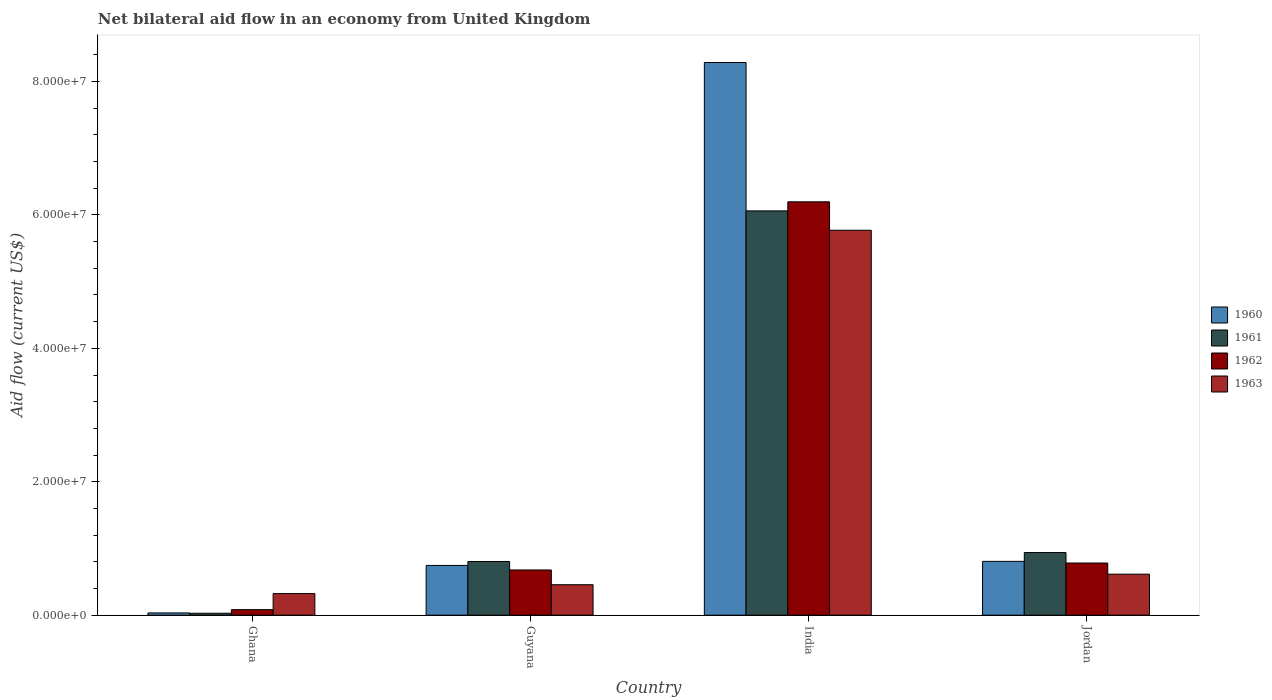How many different coloured bars are there?
Provide a succinct answer. 4. How many groups of bars are there?
Your response must be concise. 4. What is the label of the 3rd group of bars from the left?
Provide a short and direct response. India. In how many cases, is the number of bars for a given country not equal to the number of legend labels?
Offer a very short reply. 0. What is the net bilateral aid flow in 1960 in Guyana?
Keep it short and to the point. 7.46e+06. Across all countries, what is the maximum net bilateral aid flow in 1960?
Provide a short and direct response. 8.28e+07. In which country was the net bilateral aid flow in 1962 minimum?
Ensure brevity in your answer.  Ghana. What is the total net bilateral aid flow in 1962 in the graph?
Ensure brevity in your answer.  7.74e+07. What is the difference between the net bilateral aid flow in 1961 in Guyana and that in Jordan?
Offer a terse response. -1.34e+06. What is the difference between the net bilateral aid flow in 1963 in Guyana and the net bilateral aid flow in 1961 in Ghana?
Keep it short and to the point. 4.28e+06. What is the average net bilateral aid flow in 1960 per country?
Your answer should be very brief. 2.47e+07. What is the difference between the net bilateral aid flow of/in 1960 and net bilateral aid flow of/in 1961 in India?
Keep it short and to the point. 2.22e+07. What is the ratio of the net bilateral aid flow in 1962 in Ghana to that in Guyana?
Provide a short and direct response. 0.12. Is the difference between the net bilateral aid flow in 1960 in Ghana and India greater than the difference between the net bilateral aid flow in 1961 in Ghana and India?
Make the answer very short. No. What is the difference between the highest and the second highest net bilateral aid flow in 1962?
Provide a succinct answer. 5.52e+07. What is the difference between the highest and the lowest net bilateral aid flow in 1961?
Your answer should be compact. 6.03e+07. Is the sum of the net bilateral aid flow in 1961 in Ghana and India greater than the maximum net bilateral aid flow in 1962 across all countries?
Keep it short and to the point. No. Is it the case that in every country, the sum of the net bilateral aid flow in 1963 and net bilateral aid flow in 1960 is greater than the net bilateral aid flow in 1961?
Make the answer very short. Yes. How many countries are there in the graph?
Your answer should be compact. 4. What is the difference between two consecutive major ticks on the Y-axis?
Your answer should be very brief. 2.00e+07. Does the graph contain grids?
Give a very brief answer. No. What is the title of the graph?
Ensure brevity in your answer.  Net bilateral aid flow in an economy from United Kingdom. What is the label or title of the X-axis?
Offer a very short reply. Country. What is the Aid flow (current US$) of 1962 in Ghana?
Provide a short and direct response. 8.30e+05. What is the Aid flow (current US$) of 1963 in Ghana?
Your answer should be very brief. 3.24e+06. What is the Aid flow (current US$) of 1960 in Guyana?
Provide a succinct answer. 7.46e+06. What is the Aid flow (current US$) in 1961 in Guyana?
Ensure brevity in your answer.  8.05e+06. What is the Aid flow (current US$) in 1962 in Guyana?
Keep it short and to the point. 6.78e+06. What is the Aid flow (current US$) in 1963 in Guyana?
Your answer should be very brief. 4.57e+06. What is the Aid flow (current US$) of 1960 in India?
Provide a short and direct response. 8.28e+07. What is the Aid flow (current US$) in 1961 in India?
Make the answer very short. 6.06e+07. What is the Aid flow (current US$) of 1962 in India?
Keep it short and to the point. 6.20e+07. What is the Aid flow (current US$) in 1963 in India?
Provide a succinct answer. 5.77e+07. What is the Aid flow (current US$) in 1960 in Jordan?
Make the answer very short. 8.07e+06. What is the Aid flow (current US$) in 1961 in Jordan?
Your answer should be compact. 9.39e+06. What is the Aid flow (current US$) in 1962 in Jordan?
Make the answer very short. 7.82e+06. What is the Aid flow (current US$) of 1963 in Jordan?
Your answer should be very brief. 6.15e+06. Across all countries, what is the maximum Aid flow (current US$) in 1960?
Make the answer very short. 8.28e+07. Across all countries, what is the maximum Aid flow (current US$) in 1961?
Your answer should be compact. 6.06e+07. Across all countries, what is the maximum Aid flow (current US$) in 1962?
Make the answer very short. 6.20e+07. Across all countries, what is the maximum Aid flow (current US$) in 1963?
Your answer should be very brief. 5.77e+07. Across all countries, what is the minimum Aid flow (current US$) in 1961?
Give a very brief answer. 2.90e+05. Across all countries, what is the minimum Aid flow (current US$) in 1962?
Your response must be concise. 8.30e+05. Across all countries, what is the minimum Aid flow (current US$) in 1963?
Your response must be concise. 3.24e+06. What is the total Aid flow (current US$) in 1960 in the graph?
Offer a terse response. 9.87e+07. What is the total Aid flow (current US$) of 1961 in the graph?
Your answer should be compact. 7.83e+07. What is the total Aid flow (current US$) in 1962 in the graph?
Your response must be concise. 7.74e+07. What is the total Aid flow (current US$) of 1963 in the graph?
Ensure brevity in your answer.  7.17e+07. What is the difference between the Aid flow (current US$) in 1960 in Ghana and that in Guyana?
Provide a short and direct response. -7.12e+06. What is the difference between the Aid flow (current US$) of 1961 in Ghana and that in Guyana?
Offer a very short reply. -7.76e+06. What is the difference between the Aid flow (current US$) in 1962 in Ghana and that in Guyana?
Provide a short and direct response. -5.95e+06. What is the difference between the Aid flow (current US$) of 1963 in Ghana and that in Guyana?
Keep it short and to the point. -1.33e+06. What is the difference between the Aid flow (current US$) in 1960 in Ghana and that in India?
Keep it short and to the point. -8.25e+07. What is the difference between the Aid flow (current US$) of 1961 in Ghana and that in India?
Offer a very short reply. -6.03e+07. What is the difference between the Aid flow (current US$) in 1962 in Ghana and that in India?
Make the answer very short. -6.11e+07. What is the difference between the Aid flow (current US$) in 1963 in Ghana and that in India?
Keep it short and to the point. -5.45e+07. What is the difference between the Aid flow (current US$) of 1960 in Ghana and that in Jordan?
Offer a terse response. -7.73e+06. What is the difference between the Aid flow (current US$) in 1961 in Ghana and that in Jordan?
Your answer should be very brief. -9.10e+06. What is the difference between the Aid flow (current US$) of 1962 in Ghana and that in Jordan?
Make the answer very short. -6.99e+06. What is the difference between the Aid flow (current US$) in 1963 in Ghana and that in Jordan?
Offer a very short reply. -2.91e+06. What is the difference between the Aid flow (current US$) in 1960 in Guyana and that in India?
Ensure brevity in your answer.  -7.54e+07. What is the difference between the Aid flow (current US$) in 1961 in Guyana and that in India?
Your response must be concise. -5.26e+07. What is the difference between the Aid flow (current US$) in 1962 in Guyana and that in India?
Offer a terse response. -5.52e+07. What is the difference between the Aid flow (current US$) of 1963 in Guyana and that in India?
Ensure brevity in your answer.  -5.31e+07. What is the difference between the Aid flow (current US$) of 1960 in Guyana and that in Jordan?
Ensure brevity in your answer.  -6.10e+05. What is the difference between the Aid flow (current US$) in 1961 in Guyana and that in Jordan?
Keep it short and to the point. -1.34e+06. What is the difference between the Aid flow (current US$) of 1962 in Guyana and that in Jordan?
Your response must be concise. -1.04e+06. What is the difference between the Aid flow (current US$) in 1963 in Guyana and that in Jordan?
Your answer should be compact. -1.58e+06. What is the difference between the Aid flow (current US$) of 1960 in India and that in Jordan?
Your response must be concise. 7.48e+07. What is the difference between the Aid flow (current US$) in 1961 in India and that in Jordan?
Offer a very short reply. 5.12e+07. What is the difference between the Aid flow (current US$) of 1962 in India and that in Jordan?
Make the answer very short. 5.41e+07. What is the difference between the Aid flow (current US$) of 1963 in India and that in Jordan?
Provide a succinct answer. 5.16e+07. What is the difference between the Aid flow (current US$) of 1960 in Ghana and the Aid flow (current US$) of 1961 in Guyana?
Offer a very short reply. -7.71e+06. What is the difference between the Aid flow (current US$) of 1960 in Ghana and the Aid flow (current US$) of 1962 in Guyana?
Keep it short and to the point. -6.44e+06. What is the difference between the Aid flow (current US$) of 1960 in Ghana and the Aid flow (current US$) of 1963 in Guyana?
Provide a short and direct response. -4.23e+06. What is the difference between the Aid flow (current US$) of 1961 in Ghana and the Aid flow (current US$) of 1962 in Guyana?
Provide a short and direct response. -6.49e+06. What is the difference between the Aid flow (current US$) of 1961 in Ghana and the Aid flow (current US$) of 1963 in Guyana?
Make the answer very short. -4.28e+06. What is the difference between the Aid flow (current US$) in 1962 in Ghana and the Aid flow (current US$) in 1963 in Guyana?
Keep it short and to the point. -3.74e+06. What is the difference between the Aid flow (current US$) of 1960 in Ghana and the Aid flow (current US$) of 1961 in India?
Keep it short and to the point. -6.03e+07. What is the difference between the Aid flow (current US$) of 1960 in Ghana and the Aid flow (current US$) of 1962 in India?
Your response must be concise. -6.16e+07. What is the difference between the Aid flow (current US$) of 1960 in Ghana and the Aid flow (current US$) of 1963 in India?
Make the answer very short. -5.74e+07. What is the difference between the Aid flow (current US$) in 1961 in Ghana and the Aid flow (current US$) in 1962 in India?
Make the answer very short. -6.17e+07. What is the difference between the Aid flow (current US$) in 1961 in Ghana and the Aid flow (current US$) in 1963 in India?
Offer a terse response. -5.74e+07. What is the difference between the Aid flow (current US$) of 1962 in Ghana and the Aid flow (current US$) of 1963 in India?
Your answer should be very brief. -5.69e+07. What is the difference between the Aid flow (current US$) of 1960 in Ghana and the Aid flow (current US$) of 1961 in Jordan?
Offer a very short reply. -9.05e+06. What is the difference between the Aid flow (current US$) in 1960 in Ghana and the Aid flow (current US$) in 1962 in Jordan?
Provide a short and direct response. -7.48e+06. What is the difference between the Aid flow (current US$) in 1960 in Ghana and the Aid flow (current US$) in 1963 in Jordan?
Your answer should be very brief. -5.81e+06. What is the difference between the Aid flow (current US$) in 1961 in Ghana and the Aid flow (current US$) in 1962 in Jordan?
Your answer should be very brief. -7.53e+06. What is the difference between the Aid flow (current US$) in 1961 in Ghana and the Aid flow (current US$) in 1963 in Jordan?
Make the answer very short. -5.86e+06. What is the difference between the Aid flow (current US$) in 1962 in Ghana and the Aid flow (current US$) in 1963 in Jordan?
Your response must be concise. -5.32e+06. What is the difference between the Aid flow (current US$) in 1960 in Guyana and the Aid flow (current US$) in 1961 in India?
Your answer should be very brief. -5.31e+07. What is the difference between the Aid flow (current US$) of 1960 in Guyana and the Aid flow (current US$) of 1962 in India?
Offer a very short reply. -5.45e+07. What is the difference between the Aid flow (current US$) of 1960 in Guyana and the Aid flow (current US$) of 1963 in India?
Keep it short and to the point. -5.02e+07. What is the difference between the Aid flow (current US$) of 1961 in Guyana and the Aid flow (current US$) of 1962 in India?
Provide a succinct answer. -5.39e+07. What is the difference between the Aid flow (current US$) in 1961 in Guyana and the Aid flow (current US$) in 1963 in India?
Your answer should be very brief. -4.96e+07. What is the difference between the Aid flow (current US$) of 1962 in Guyana and the Aid flow (current US$) of 1963 in India?
Provide a short and direct response. -5.09e+07. What is the difference between the Aid flow (current US$) of 1960 in Guyana and the Aid flow (current US$) of 1961 in Jordan?
Provide a succinct answer. -1.93e+06. What is the difference between the Aid flow (current US$) of 1960 in Guyana and the Aid flow (current US$) of 1962 in Jordan?
Your response must be concise. -3.60e+05. What is the difference between the Aid flow (current US$) of 1960 in Guyana and the Aid flow (current US$) of 1963 in Jordan?
Offer a very short reply. 1.31e+06. What is the difference between the Aid flow (current US$) in 1961 in Guyana and the Aid flow (current US$) in 1963 in Jordan?
Your response must be concise. 1.90e+06. What is the difference between the Aid flow (current US$) of 1962 in Guyana and the Aid flow (current US$) of 1963 in Jordan?
Give a very brief answer. 6.30e+05. What is the difference between the Aid flow (current US$) of 1960 in India and the Aid flow (current US$) of 1961 in Jordan?
Make the answer very short. 7.34e+07. What is the difference between the Aid flow (current US$) of 1960 in India and the Aid flow (current US$) of 1962 in Jordan?
Provide a short and direct response. 7.50e+07. What is the difference between the Aid flow (current US$) in 1960 in India and the Aid flow (current US$) in 1963 in Jordan?
Ensure brevity in your answer.  7.67e+07. What is the difference between the Aid flow (current US$) of 1961 in India and the Aid flow (current US$) of 1962 in Jordan?
Give a very brief answer. 5.28e+07. What is the difference between the Aid flow (current US$) in 1961 in India and the Aid flow (current US$) in 1963 in Jordan?
Your answer should be compact. 5.44e+07. What is the difference between the Aid flow (current US$) of 1962 in India and the Aid flow (current US$) of 1963 in Jordan?
Your answer should be compact. 5.58e+07. What is the average Aid flow (current US$) in 1960 per country?
Your answer should be very brief. 2.47e+07. What is the average Aid flow (current US$) in 1961 per country?
Your answer should be compact. 1.96e+07. What is the average Aid flow (current US$) of 1962 per country?
Your response must be concise. 1.93e+07. What is the average Aid flow (current US$) of 1963 per country?
Ensure brevity in your answer.  1.79e+07. What is the difference between the Aid flow (current US$) of 1960 and Aid flow (current US$) of 1961 in Ghana?
Provide a succinct answer. 5.00e+04. What is the difference between the Aid flow (current US$) of 1960 and Aid flow (current US$) of 1962 in Ghana?
Your response must be concise. -4.90e+05. What is the difference between the Aid flow (current US$) in 1960 and Aid flow (current US$) in 1963 in Ghana?
Provide a short and direct response. -2.90e+06. What is the difference between the Aid flow (current US$) in 1961 and Aid flow (current US$) in 1962 in Ghana?
Offer a terse response. -5.40e+05. What is the difference between the Aid flow (current US$) in 1961 and Aid flow (current US$) in 1963 in Ghana?
Your response must be concise. -2.95e+06. What is the difference between the Aid flow (current US$) in 1962 and Aid flow (current US$) in 1963 in Ghana?
Keep it short and to the point. -2.41e+06. What is the difference between the Aid flow (current US$) of 1960 and Aid flow (current US$) of 1961 in Guyana?
Keep it short and to the point. -5.90e+05. What is the difference between the Aid flow (current US$) of 1960 and Aid flow (current US$) of 1962 in Guyana?
Offer a terse response. 6.80e+05. What is the difference between the Aid flow (current US$) of 1960 and Aid flow (current US$) of 1963 in Guyana?
Offer a very short reply. 2.89e+06. What is the difference between the Aid flow (current US$) of 1961 and Aid flow (current US$) of 1962 in Guyana?
Provide a succinct answer. 1.27e+06. What is the difference between the Aid flow (current US$) in 1961 and Aid flow (current US$) in 1963 in Guyana?
Make the answer very short. 3.48e+06. What is the difference between the Aid flow (current US$) of 1962 and Aid flow (current US$) of 1963 in Guyana?
Provide a succinct answer. 2.21e+06. What is the difference between the Aid flow (current US$) of 1960 and Aid flow (current US$) of 1961 in India?
Ensure brevity in your answer.  2.22e+07. What is the difference between the Aid flow (current US$) in 1960 and Aid flow (current US$) in 1962 in India?
Provide a succinct answer. 2.09e+07. What is the difference between the Aid flow (current US$) in 1960 and Aid flow (current US$) in 1963 in India?
Give a very brief answer. 2.51e+07. What is the difference between the Aid flow (current US$) in 1961 and Aid flow (current US$) in 1962 in India?
Provide a short and direct response. -1.36e+06. What is the difference between the Aid flow (current US$) of 1961 and Aid flow (current US$) of 1963 in India?
Offer a terse response. 2.90e+06. What is the difference between the Aid flow (current US$) in 1962 and Aid flow (current US$) in 1963 in India?
Your answer should be very brief. 4.26e+06. What is the difference between the Aid flow (current US$) in 1960 and Aid flow (current US$) in 1961 in Jordan?
Provide a short and direct response. -1.32e+06. What is the difference between the Aid flow (current US$) of 1960 and Aid flow (current US$) of 1963 in Jordan?
Provide a short and direct response. 1.92e+06. What is the difference between the Aid flow (current US$) in 1961 and Aid flow (current US$) in 1962 in Jordan?
Provide a short and direct response. 1.57e+06. What is the difference between the Aid flow (current US$) in 1961 and Aid flow (current US$) in 1963 in Jordan?
Provide a succinct answer. 3.24e+06. What is the difference between the Aid flow (current US$) of 1962 and Aid flow (current US$) of 1963 in Jordan?
Provide a succinct answer. 1.67e+06. What is the ratio of the Aid flow (current US$) in 1960 in Ghana to that in Guyana?
Your response must be concise. 0.05. What is the ratio of the Aid flow (current US$) in 1961 in Ghana to that in Guyana?
Offer a very short reply. 0.04. What is the ratio of the Aid flow (current US$) in 1962 in Ghana to that in Guyana?
Your answer should be very brief. 0.12. What is the ratio of the Aid flow (current US$) of 1963 in Ghana to that in Guyana?
Offer a very short reply. 0.71. What is the ratio of the Aid flow (current US$) of 1960 in Ghana to that in India?
Provide a short and direct response. 0. What is the ratio of the Aid flow (current US$) in 1961 in Ghana to that in India?
Provide a short and direct response. 0. What is the ratio of the Aid flow (current US$) of 1962 in Ghana to that in India?
Offer a terse response. 0.01. What is the ratio of the Aid flow (current US$) of 1963 in Ghana to that in India?
Offer a terse response. 0.06. What is the ratio of the Aid flow (current US$) of 1960 in Ghana to that in Jordan?
Ensure brevity in your answer.  0.04. What is the ratio of the Aid flow (current US$) in 1961 in Ghana to that in Jordan?
Your answer should be very brief. 0.03. What is the ratio of the Aid flow (current US$) in 1962 in Ghana to that in Jordan?
Your answer should be very brief. 0.11. What is the ratio of the Aid flow (current US$) in 1963 in Ghana to that in Jordan?
Provide a short and direct response. 0.53. What is the ratio of the Aid flow (current US$) in 1960 in Guyana to that in India?
Your response must be concise. 0.09. What is the ratio of the Aid flow (current US$) in 1961 in Guyana to that in India?
Your response must be concise. 0.13. What is the ratio of the Aid flow (current US$) in 1962 in Guyana to that in India?
Offer a terse response. 0.11. What is the ratio of the Aid flow (current US$) in 1963 in Guyana to that in India?
Give a very brief answer. 0.08. What is the ratio of the Aid flow (current US$) of 1960 in Guyana to that in Jordan?
Your answer should be very brief. 0.92. What is the ratio of the Aid flow (current US$) of 1961 in Guyana to that in Jordan?
Provide a succinct answer. 0.86. What is the ratio of the Aid flow (current US$) of 1962 in Guyana to that in Jordan?
Your answer should be very brief. 0.87. What is the ratio of the Aid flow (current US$) of 1963 in Guyana to that in Jordan?
Give a very brief answer. 0.74. What is the ratio of the Aid flow (current US$) of 1960 in India to that in Jordan?
Provide a short and direct response. 10.27. What is the ratio of the Aid flow (current US$) in 1961 in India to that in Jordan?
Keep it short and to the point. 6.45. What is the ratio of the Aid flow (current US$) of 1962 in India to that in Jordan?
Your answer should be very brief. 7.92. What is the ratio of the Aid flow (current US$) of 1963 in India to that in Jordan?
Keep it short and to the point. 9.38. What is the difference between the highest and the second highest Aid flow (current US$) in 1960?
Provide a short and direct response. 7.48e+07. What is the difference between the highest and the second highest Aid flow (current US$) in 1961?
Your response must be concise. 5.12e+07. What is the difference between the highest and the second highest Aid flow (current US$) of 1962?
Offer a terse response. 5.41e+07. What is the difference between the highest and the second highest Aid flow (current US$) in 1963?
Keep it short and to the point. 5.16e+07. What is the difference between the highest and the lowest Aid flow (current US$) in 1960?
Offer a terse response. 8.25e+07. What is the difference between the highest and the lowest Aid flow (current US$) of 1961?
Offer a very short reply. 6.03e+07. What is the difference between the highest and the lowest Aid flow (current US$) of 1962?
Offer a terse response. 6.11e+07. What is the difference between the highest and the lowest Aid flow (current US$) of 1963?
Your response must be concise. 5.45e+07. 